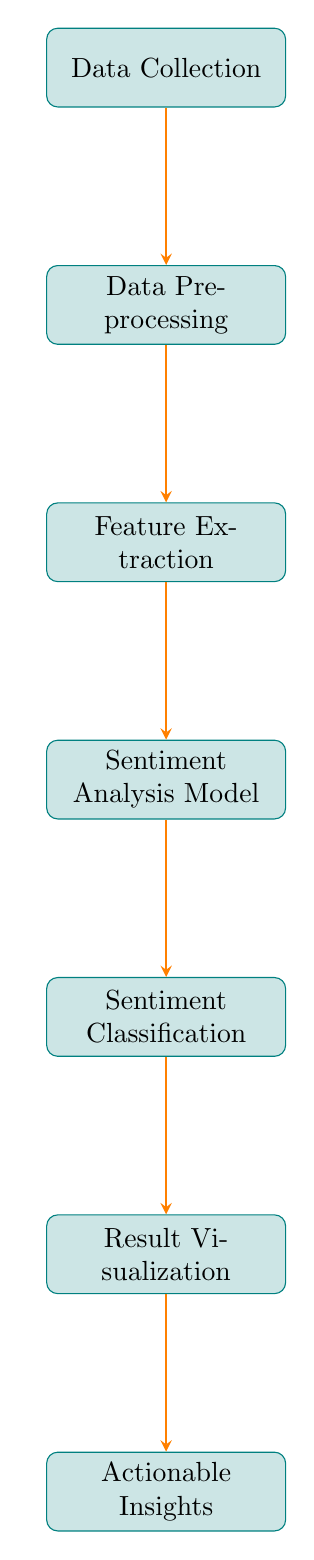What is the first step in the algorithm workflow? The first step in the algorithm workflow is "Data Collection," where customer support conversation data is gathered from various sources.
Answer: Data Collection How many nodes are present in the diagram? By counting the distinct labeled processes in the diagram, we identify a total of 7 nodes: Data Collection, Data Preprocessing, Feature Extraction, Sentiment Analysis Model, Sentiment Classification, Result Visualization, and Actionable Insights.
Answer: 7 What step comes after Feature Extraction? After Feature Extraction, the next step is "Sentiment Analysis Model," where the relevant model is applied to classify sentiments based on the extracted features.
Answer: Sentiment Analysis Model Which node leads to Actionable Insights? The node "Result Visualization" leads to "Actionable Insights," as it visualizes the results before generating insights.
Answer: Result Visualization How many edges connect the nodes in the diagram? By counting the directed links (edges) that connect the nodes from one to another, we observe 6 edges in total.
Answer: 6 What is the primary purpose of the Sentiment Classification node? The primary purpose of the Sentiment Classification node is to categorize sentences or conversation fragments as positive, negative, or neutral sentiments based on the analysis performed.
Answer: To categorize sentiments Which node serves as the last step in the workflow? The last step in the workflow is "Actionable Insights," which implies generating insights based on the sentiment analysis results visualized from the preceding node.
Answer: Actionable Insights What process immediately follows Data Preprocessing? The process that immediately follows Data Preprocessing is "Feature Extraction," where relevant features such as keywords and phrases are extracted from the cleaned data.
Answer: Feature Extraction What is the relationship between Sentiment Analysis Model and Sentiment Classification? The relationship is that the Sentiment Analysis Model directly feeds into and informs the Sentiment Classification process, as it classifies sentiments based on the output of the analysis.
Answer: Direct feed-in 